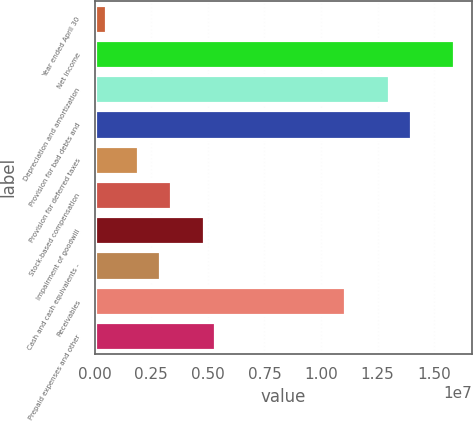Convert chart. <chart><loc_0><loc_0><loc_500><loc_500><bar_chart><fcel>Year ended April 30<fcel>Net income<fcel>Depreciation and amortization<fcel>Provision for bad debts and<fcel>Provision for deferred taxes<fcel>Stock-based compensation<fcel>Impairment of goodwill<fcel>Cash and cash equivalents -<fcel>Receivables<fcel>Prepaid expenses and other<nl><fcel>482258<fcel>1.5901e+07<fcel>1.30099e+07<fcel>1.39736e+07<fcel>1.92776e+06<fcel>3.37326e+06<fcel>4.81877e+06<fcel>2.89143e+06<fcel>1.10826e+07<fcel>5.3006e+06<nl></chart> 